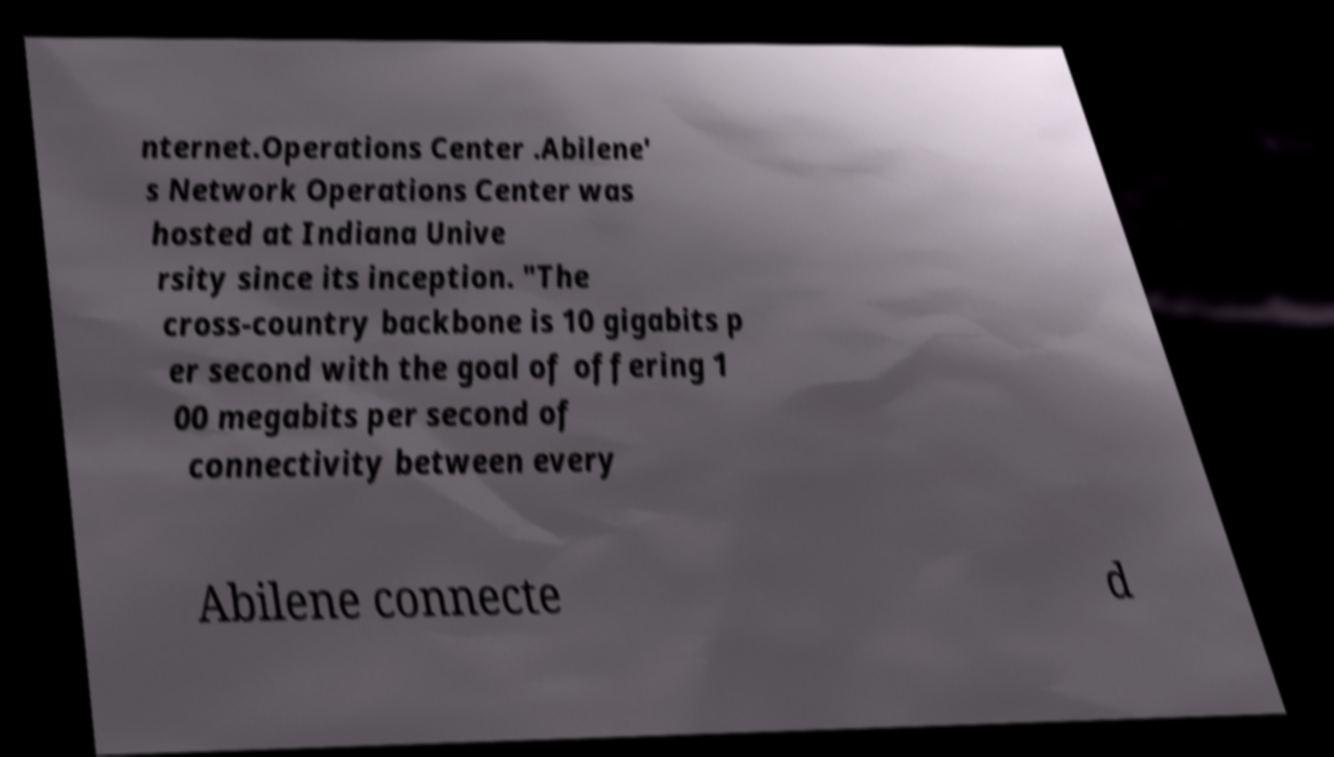Could you extract and type out the text from this image? nternet.Operations Center .Abilene' s Network Operations Center was hosted at Indiana Unive rsity since its inception. "The cross-country backbone is 10 gigabits p er second with the goal of offering 1 00 megabits per second of connectivity between every Abilene connecte d 